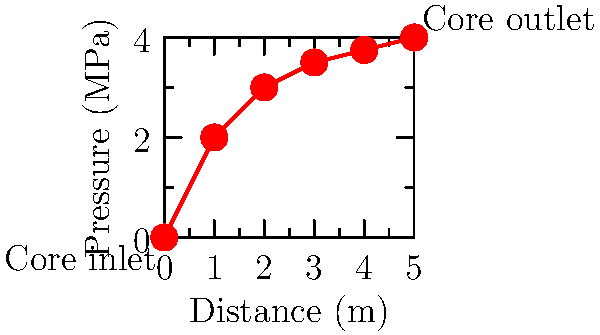Given the pressure distribution graph for a nuclear reactor core coolant flow, calculate the total pressure drop across the core. Assume the core length is 5 meters. To calculate the total pressure drop across the nuclear reactor core, we need to follow these steps:

1. Identify the inlet and outlet pressures:
   - Inlet pressure (at 0 m): $P_i = 0$ MPa
   - Outlet pressure (at 5 m): $P_o = 4$ MPa

2. Calculate the pressure drop:
   $$\Delta P = P_o - P_i$$
   $$\Delta P = 4 \text{ MPa} - 0 \text{ MPa} = 4 \text{ MPa}$$

3. Convert the pressure drop to pascals:
   $$\Delta P = 4 \text{ MPa} \times 10^6 \text{ Pa/MPa} = 4 \times 10^6 \text{ Pa}$$

The total pressure drop across the core is 4 MPa or $4 \times 10^6$ Pa.

Note: In this case, the pressure actually increases across the core, which is atypical. In most reactor designs, pressure decreases due to frictional losses. This increase could be due to factors such as coolant heating and expansion, or the presence of pumps within the core region.
Answer: 4 MPa 